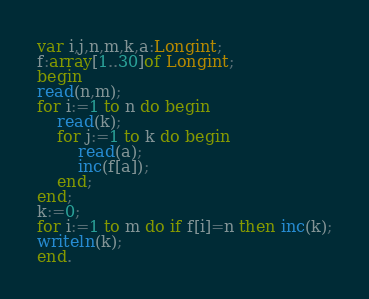<code> <loc_0><loc_0><loc_500><loc_500><_Pascal_>var i,j,n,m,k,a:Longint;
f:array[1..30]of Longint;
begin
read(n,m);
for i:=1 to n do begin
	read(k);
	for j:=1 to k do begin
		read(a);
		inc(f[a]);
	end;
end;
k:=0;
for i:=1 to m do if f[i]=n then inc(k);
writeln(k);
end.</code> 